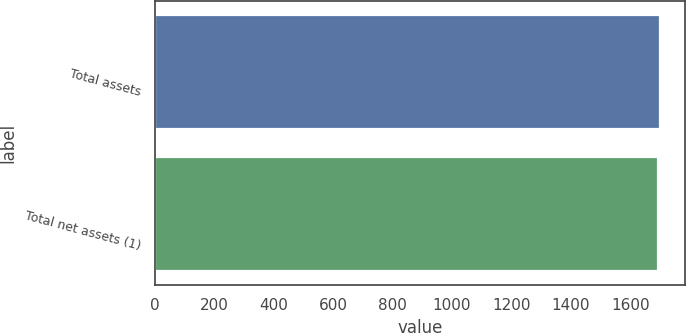<chart> <loc_0><loc_0><loc_500><loc_500><bar_chart><fcel>Total assets<fcel>Total net assets (1)<nl><fcel>1701<fcel>1692<nl></chart> 